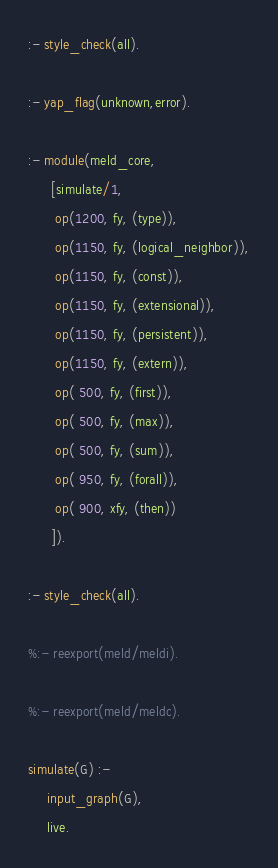<code> <loc_0><loc_0><loc_500><loc_500><_Prolog_>

:- style_check(all).

:- yap_flag(unknown,error).

:- module(meld_core,
	  [simulate/1,
	   op(1200, fy, (type)),
	   op(1150, fy, (logical_neighbor)),
	   op(1150, fy, (const)),
	   op(1150, fy, (extensional)),
	   op(1150, fy, (persistent)),
	   op(1150, fy, (extern)),
	   op( 500, fy, (first)),
	   op( 500, fy, (max)),
	   op( 500, fy, (sum)),
	   op( 950, fy, (forall)),
	   op( 900, xfy, (then))
	  ]).

:- style_check(all).

%:- reexport(meld/meldi).

%:- reexport(meld/meldc).

simulate(G) :-
	 input_graph(G),
	 live.


</code> 